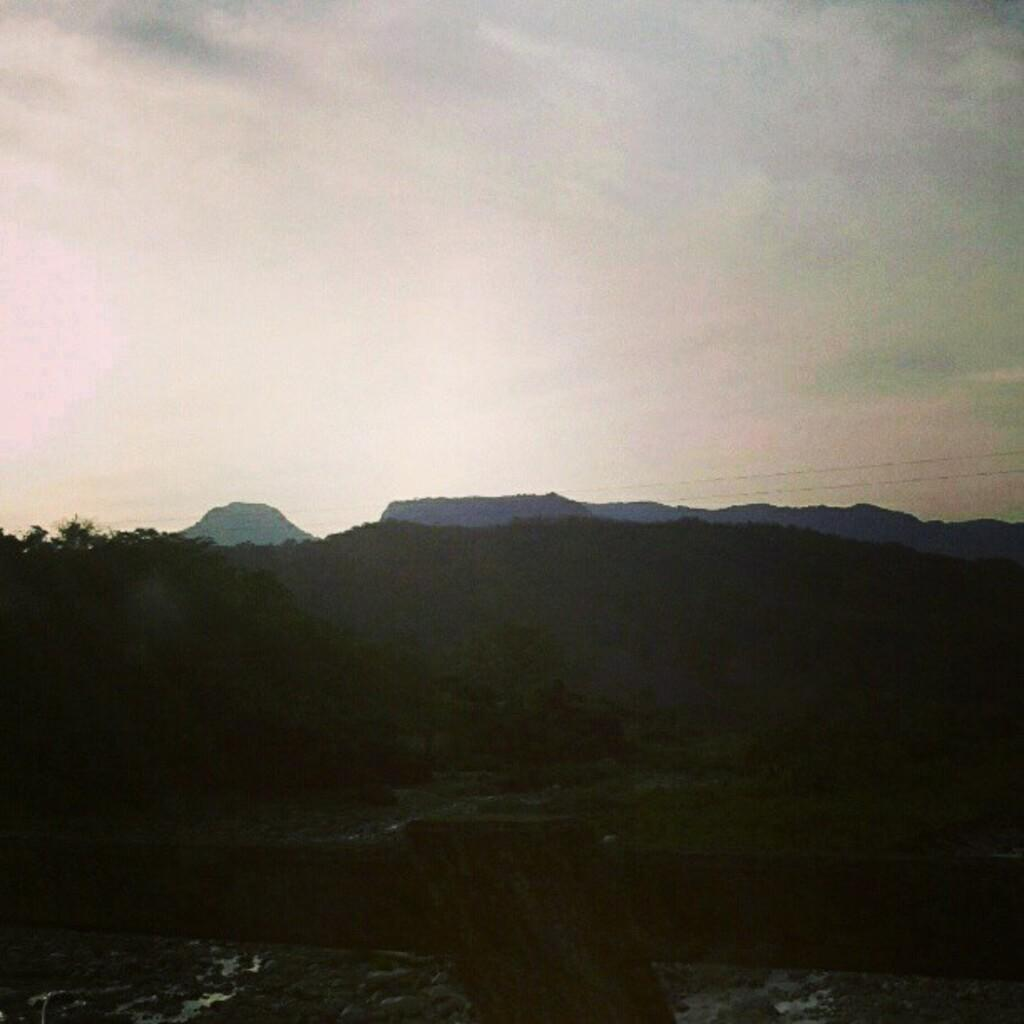What materials are present at the bottom of the image? There is wood and small stones at the bottom of the image. What can be seen on the left side of the image? There are trees on the left side of the image. What is visible in the background of the image? There are trees and hills in the background of the image. What is visible at the top of the image? The sky is visible at the top of the image. What color of paint is used to create the pen in the image? There is no pen or paint present in the image. 